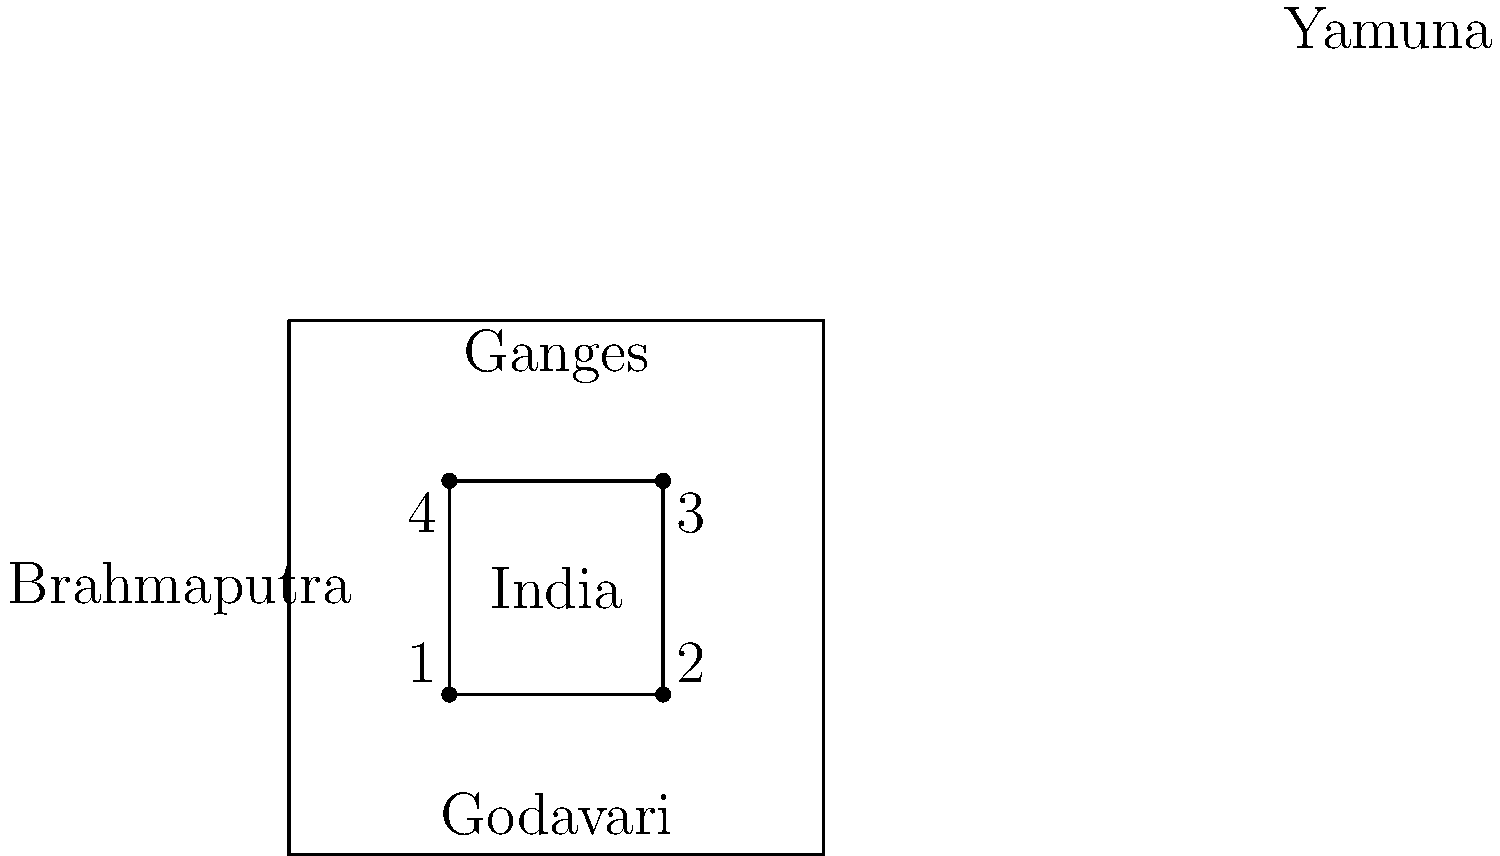On this simplified map of India, which number corresponds to the location where the Ganges River is most likely to flow? To answer this question, we need to follow these steps:

1. Identify the Ganges River on the map:
   The Ganges River is labeled at the top of the map.

2. Understand the geography of the Ganges River:
   The Ganges flows from the northern part of India towards the east.

3. Locate the northern part of the simplified map:
   The top of the square represents the northern part of India.

4. Identify the numbered points:
   There are four numbered points (1, 2, 3, and 4) on the inner square.

5. Determine which point is in the northern part of the map:
   Points 1 and 4 are in the northern half of the map.

6. Choose the northeastern point:
   Since the Ganges flows from the north towards the east, point 1 in the northeast is the most likely location for the Ganges River to flow.
Answer: 1 